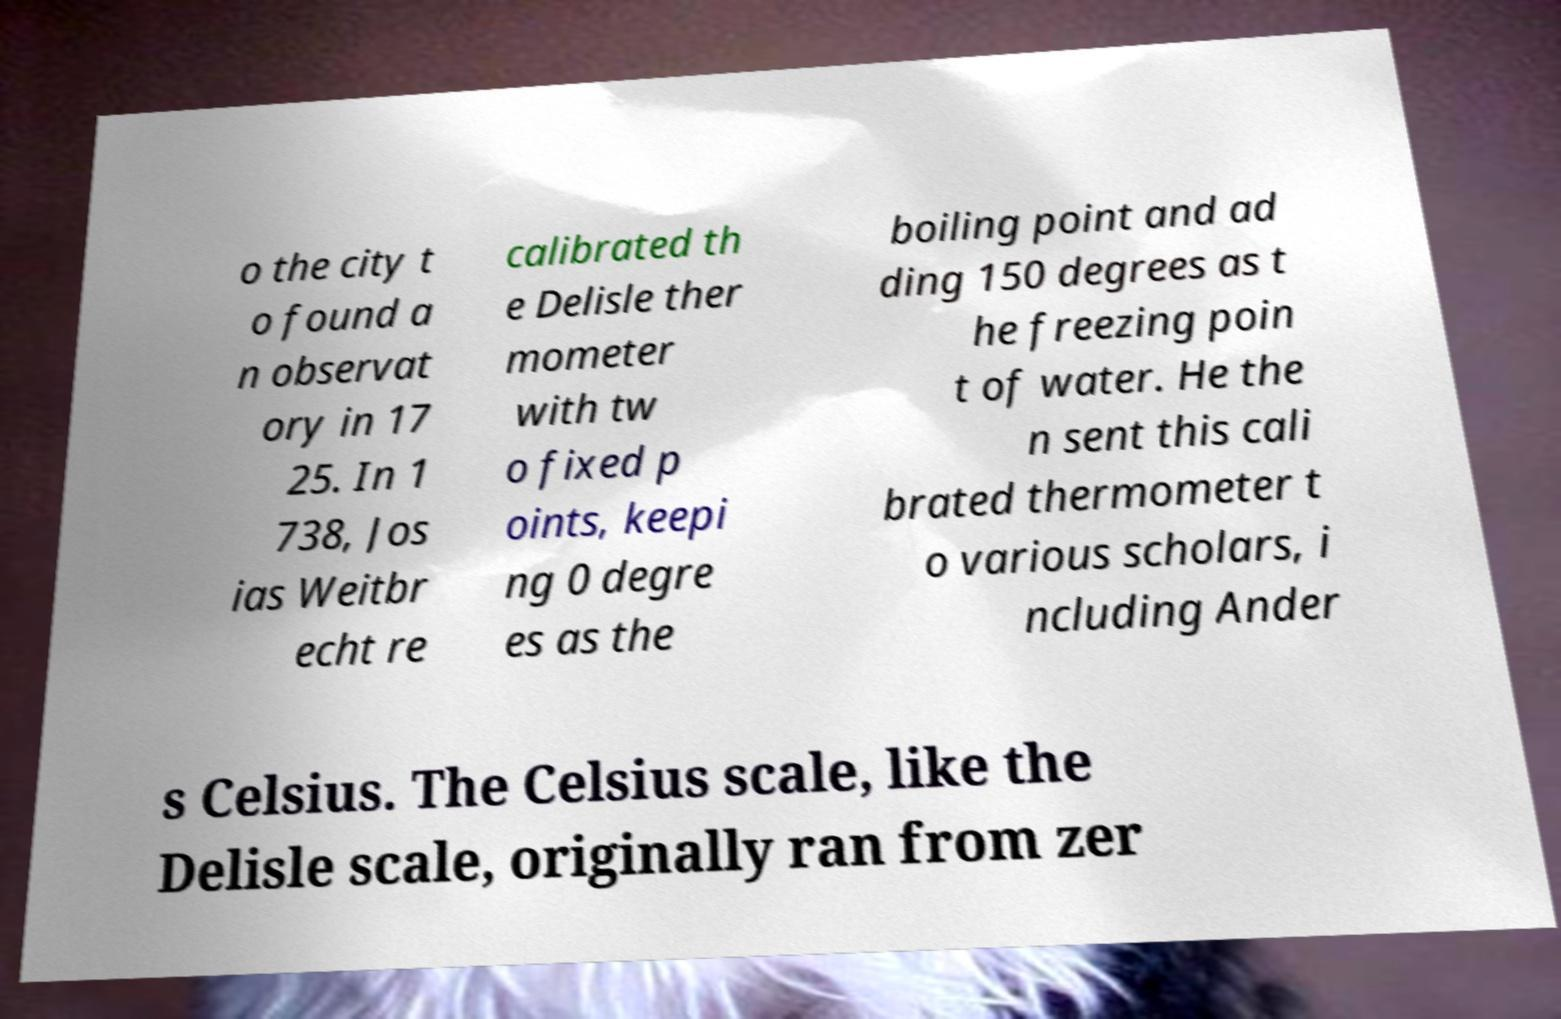Please identify and transcribe the text found in this image. o the city t o found a n observat ory in 17 25. In 1 738, Jos ias Weitbr echt re calibrated th e Delisle ther mometer with tw o fixed p oints, keepi ng 0 degre es as the boiling point and ad ding 150 degrees as t he freezing poin t of water. He the n sent this cali brated thermometer t o various scholars, i ncluding Ander s Celsius. The Celsius scale, like the Delisle scale, originally ran from zer 